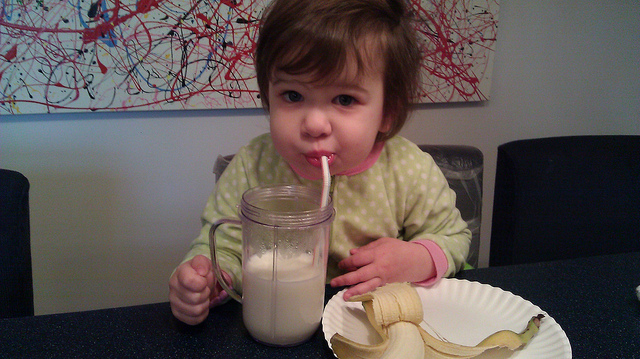<image>Is the milk organic? I don't know if the milk is organic. It can be either organic or not. Is the milk organic? I don't know if the milk is organic or not. 